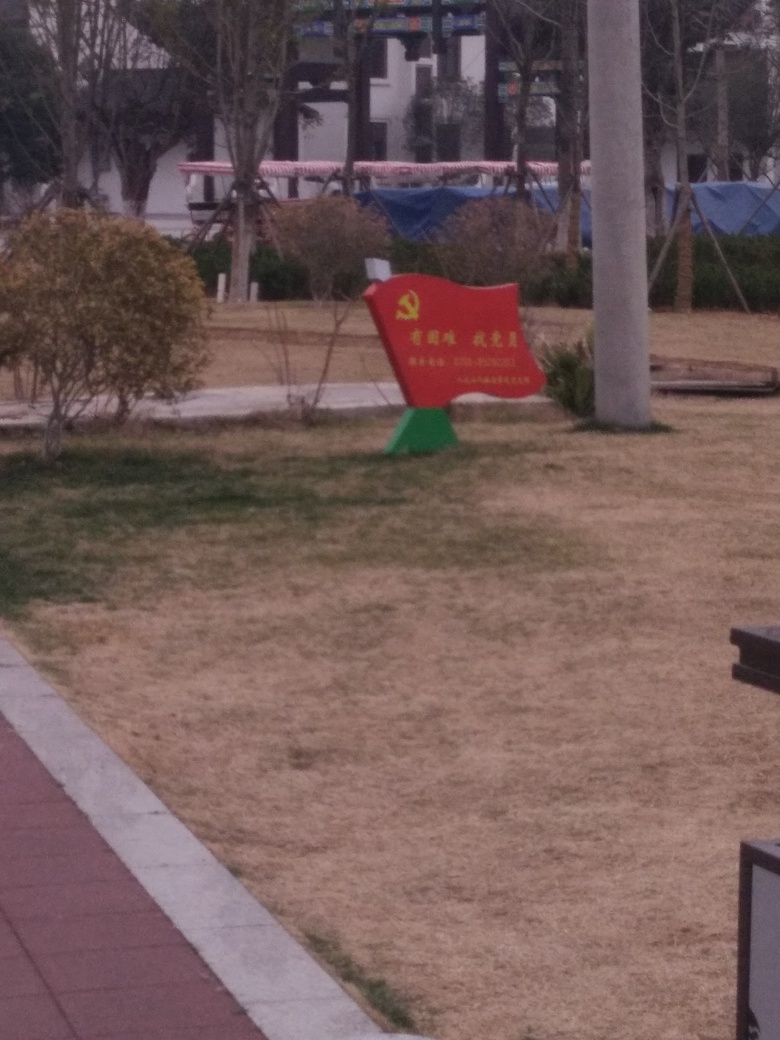What can be said about the content of this image?
A. vibrant
B. monotonous
C. diverse
Answer with the option's letter from the given choices directly. The content of the image can be described as 'B. monotonous.' The area is primarily covered in dry, uniform grass with no significant variation in color or texture. The objects within the scene, such as the solitary red bench with a symbol, do not add substantial vibrancy or diversity to the overall visual interest. 